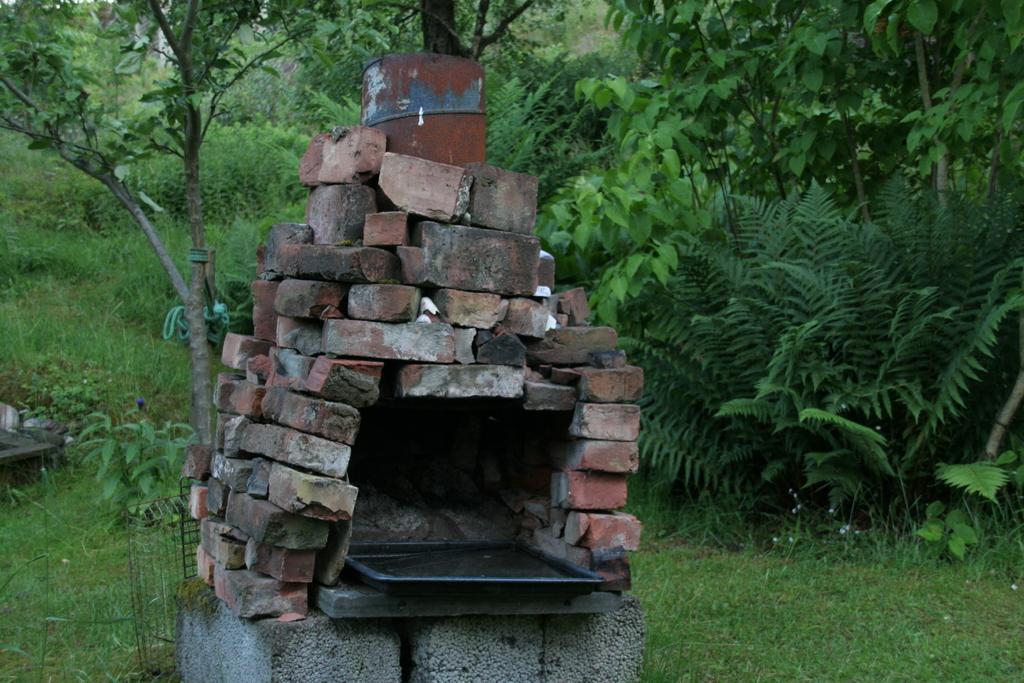Could you give a brief overview of what you see in this image? In this image there is a large utepeis made up of bricks, and in the background there is grass, plants , trees. 